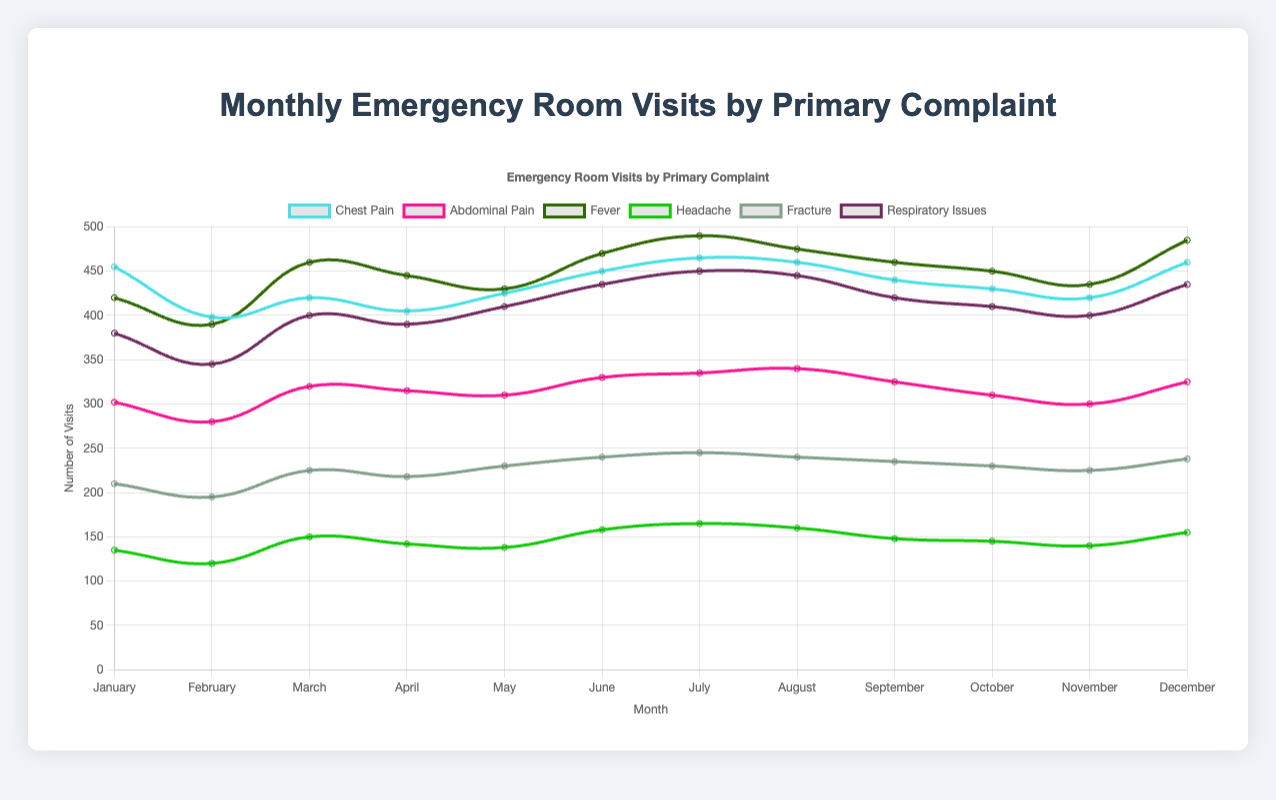What is the trend of "Chest Pain" complaints over the year? The "Chest Pain" line shows a fluctuating pattern, starting at 455 in January, declining in February (398), then fluctuating between 420 and 465 for the remaining months, and ending at 460 in December.
Answer: Fluctuating, with a peak in July (465) and a low in February (398) How do the number of "Headache" complaints in June compare to those in July? To compare, observe the "Headache" line for June and July. June shows 158 complaints, while July has 165. Thus, there are more "Headache" complaints in July than in June.
Answer: More in July Which month has the highest number of "Fever" complaints? The "Fever" line peaks in July at 490 complaints, which is higher than any other month.
Answer: July What is the sum of "Abdominal Pain" complaints over January and February? January has 302 "Abdominal Pain" complaints, and February has 280. Adding them together, 302 + 280 = 582.
Answer: 582 In which month does "Respiratory Issues" reach its peak, and what is the value? The "Respiratory Issues" line peaks in July with 450 complaints, which is higher than any other month.
Answer: July, 450 What is the average number of "Fracture" complaints for Q1 (January to March)? Summing the "Fracture" complaints for January (210), February (195), and March (225) gives 210 + 195 + 225 = 630. Dividing by 3 (the number of months), the average is 630 / 3 = 210.
Answer: 210 How do the "Fever" complaints in August compare to those in December? August has 475 "Fever" complaints and December has 485. Aug has 10 fewer complaints than Dec.
Answer: Fewer in August What is the difference in "Respiratory Issues" between May and October? May has 410 "Respiratory Issues" complaints, and October has 410. The difference is 410 - 410 = 0.
Answer: 0 How many more "Chest Pain" complaints are there in July compared to April? July has 465 "Chest Pain" complaints whereas April has 405. The difference is 465 - 405 = 60.
Answer: 60 Which complaint shows the least fluctuation over the year, visually? The "Abdominal Pain" line shows relatively small fluctuations compared to other lines, remaining between 280 and 340 throughout the year.
Answer: Abdominal Pain 